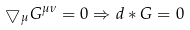<formula> <loc_0><loc_0><loc_500><loc_500>\bigtriangledown _ { \mu } G ^ { \mu \nu } = 0 \Rightarrow d * G = 0</formula> 